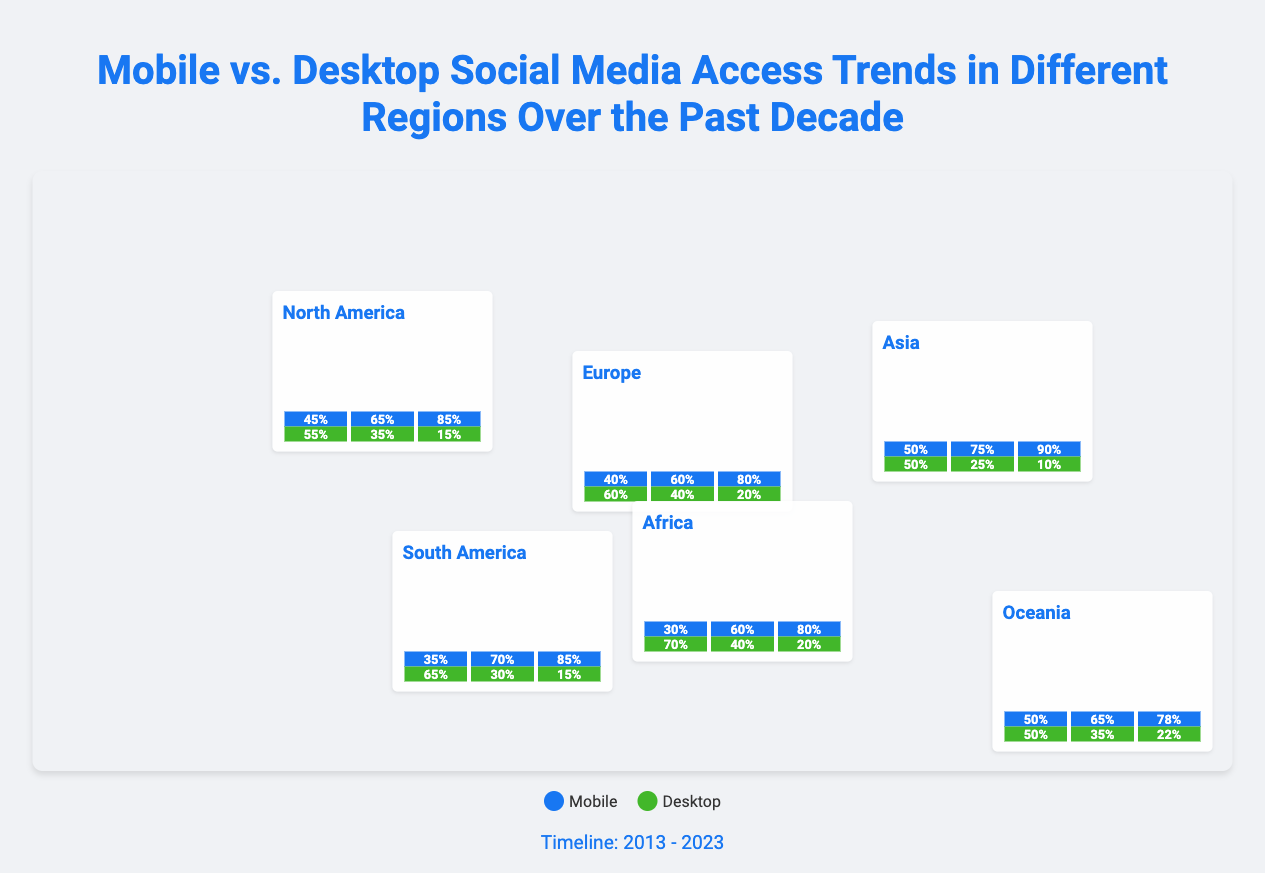what percentage of social media access in North America was mobile in 2023? The document shows that the mobile access in North America in 2023 is represented as 85% in the chart.
Answer: 85% which region had the highest percentage of mobile access in 2023? By comparing the 2023 data across all regions, Asia has the highest mobile access percentage at 90%.
Answer: Asia what was the mobile access percentage in Europe in 2018? The chart indicates that in 2018, the mobile access percentage in Europe was 60%.
Answer: 60% which region consistently showed higher desktop access than mobile access in 2013? Based on the data, South America had higher desktop access than mobile access in 2013 with 65% desktop compared to 35% mobile.
Answer: South America what happened to mobile access in Africa from 2013 to 2023? The data indicates that mobile access in Africa increased from 30% in 2013 to 80% in 2023.
Answer: Increased which device type is represented by the color blue in the legend? In the document, blue color indicates mobile access based on the legend.
Answer: Mobile what is the timeline period covered in the infographic? The timeline mentioned in the infographic spans from the year 2013 to 2023.
Answer: 2013 - 2023 which region had the lowest percentage of mobile access in 2023? According to the data, Africa had the lowest mobile access percentage at 80% in 2023.
Answer: Africa what was the mobile access percentage in Oceania in 2018? The chart shows that in 2018, the mobile access percentage in Oceania was 65%.
Answer: 65% 